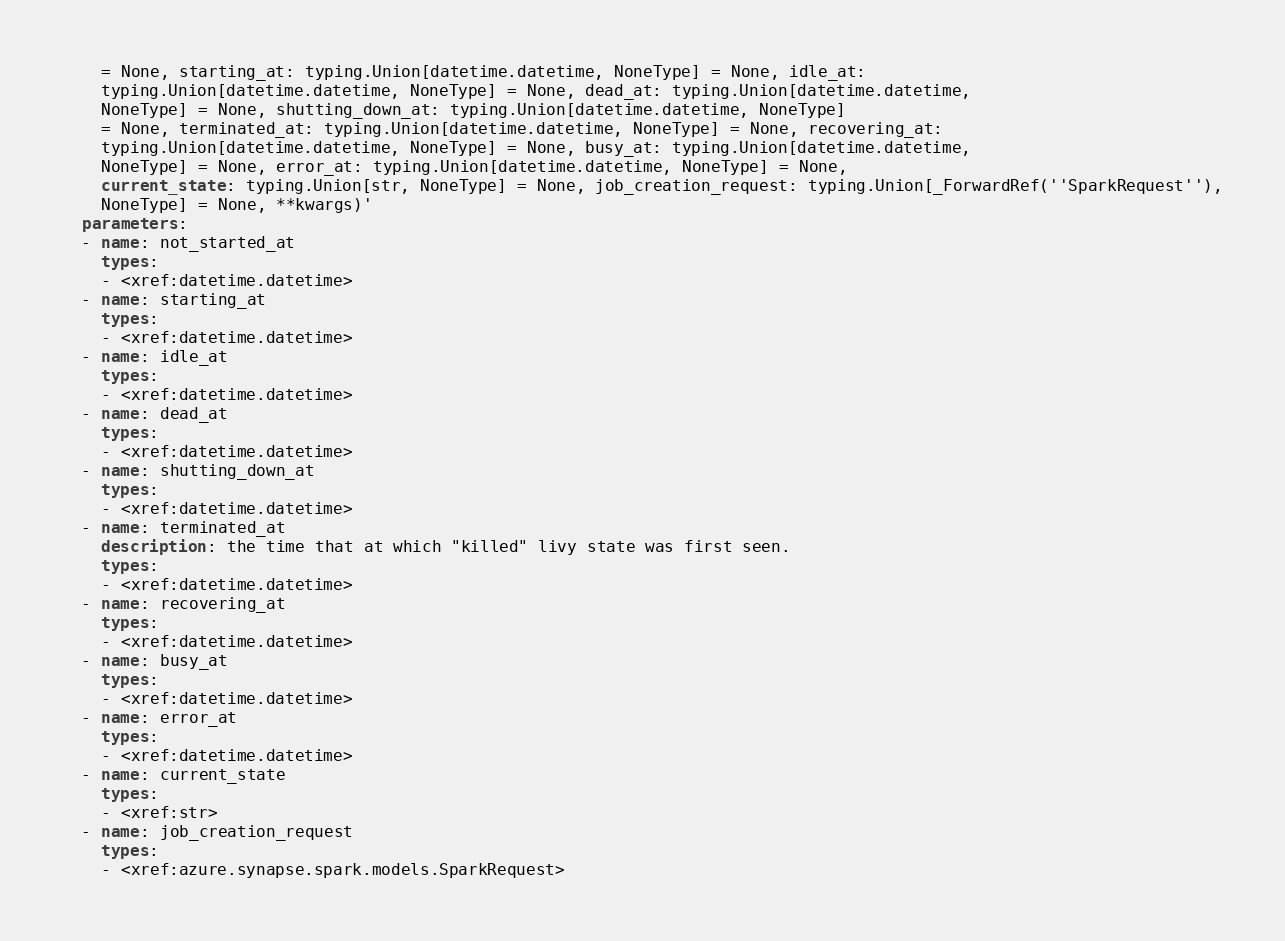Convert code to text. <code><loc_0><loc_0><loc_500><loc_500><_YAML_>    = None, starting_at: typing.Union[datetime.datetime, NoneType] = None, idle_at:
    typing.Union[datetime.datetime, NoneType] = None, dead_at: typing.Union[datetime.datetime,
    NoneType] = None, shutting_down_at: typing.Union[datetime.datetime, NoneType]
    = None, terminated_at: typing.Union[datetime.datetime, NoneType] = None, recovering_at:
    typing.Union[datetime.datetime, NoneType] = None, busy_at: typing.Union[datetime.datetime,
    NoneType] = None, error_at: typing.Union[datetime.datetime, NoneType] = None,
    current_state: typing.Union[str, NoneType] = None, job_creation_request: typing.Union[_ForwardRef(''SparkRequest''),
    NoneType] = None, **kwargs)'
  parameters:
  - name: not_started_at
    types:
    - <xref:datetime.datetime>
  - name: starting_at
    types:
    - <xref:datetime.datetime>
  - name: idle_at
    types:
    - <xref:datetime.datetime>
  - name: dead_at
    types:
    - <xref:datetime.datetime>
  - name: shutting_down_at
    types:
    - <xref:datetime.datetime>
  - name: terminated_at
    description: the time that at which "killed" livy state was first seen.
    types:
    - <xref:datetime.datetime>
  - name: recovering_at
    types:
    - <xref:datetime.datetime>
  - name: busy_at
    types:
    - <xref:datetime.datetime>
  - name: error_at
    types:
    - <xref:datetime.datetime>
  - name: current_state
    types:
    - <xref:str>
  - name: job_creation_request
    types:
    - <xref:azure.synapse.spark.models.SparkRequest>
</code> 